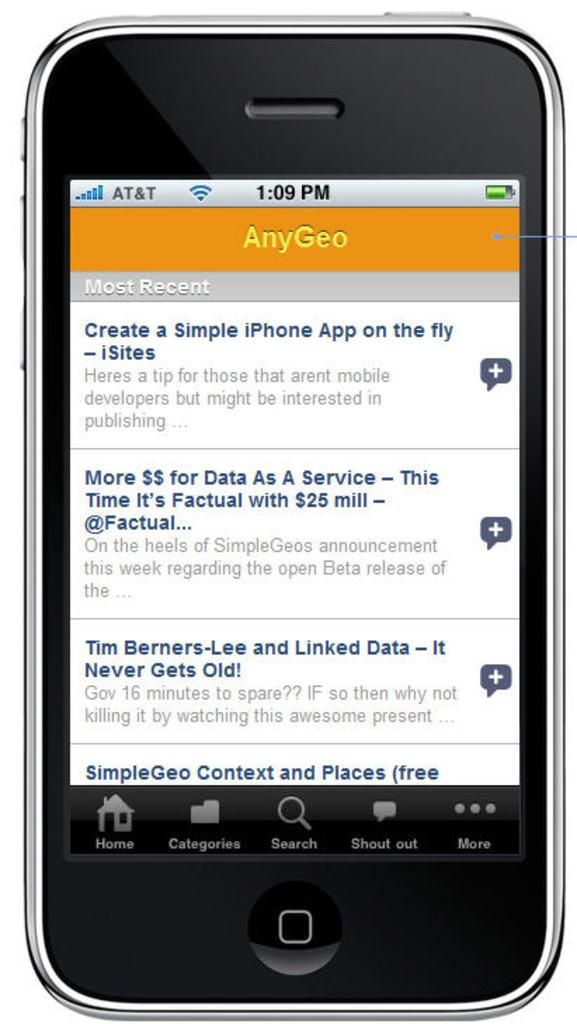Provide a one-sentence caption for the provided image. A cell phone showing an app on the screen called AnyGeo. 